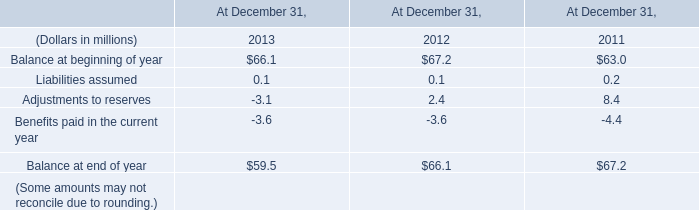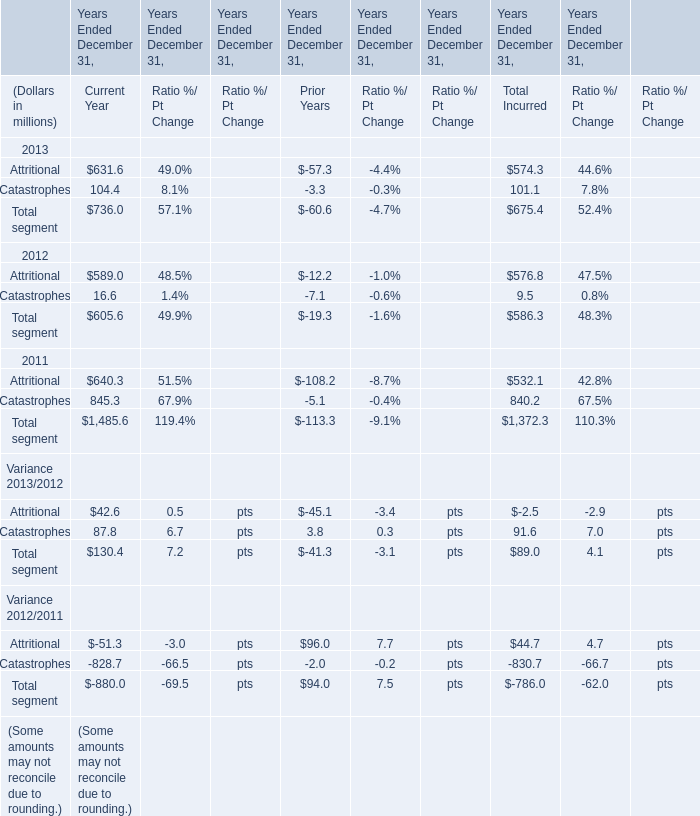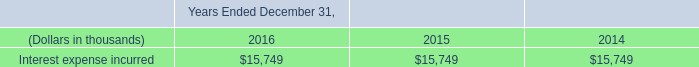As As the chart 1 shows,which Year(Ended December 31,which Year) is the value for Attritional for Current Year is the lowset? 
Answer: 2012. 